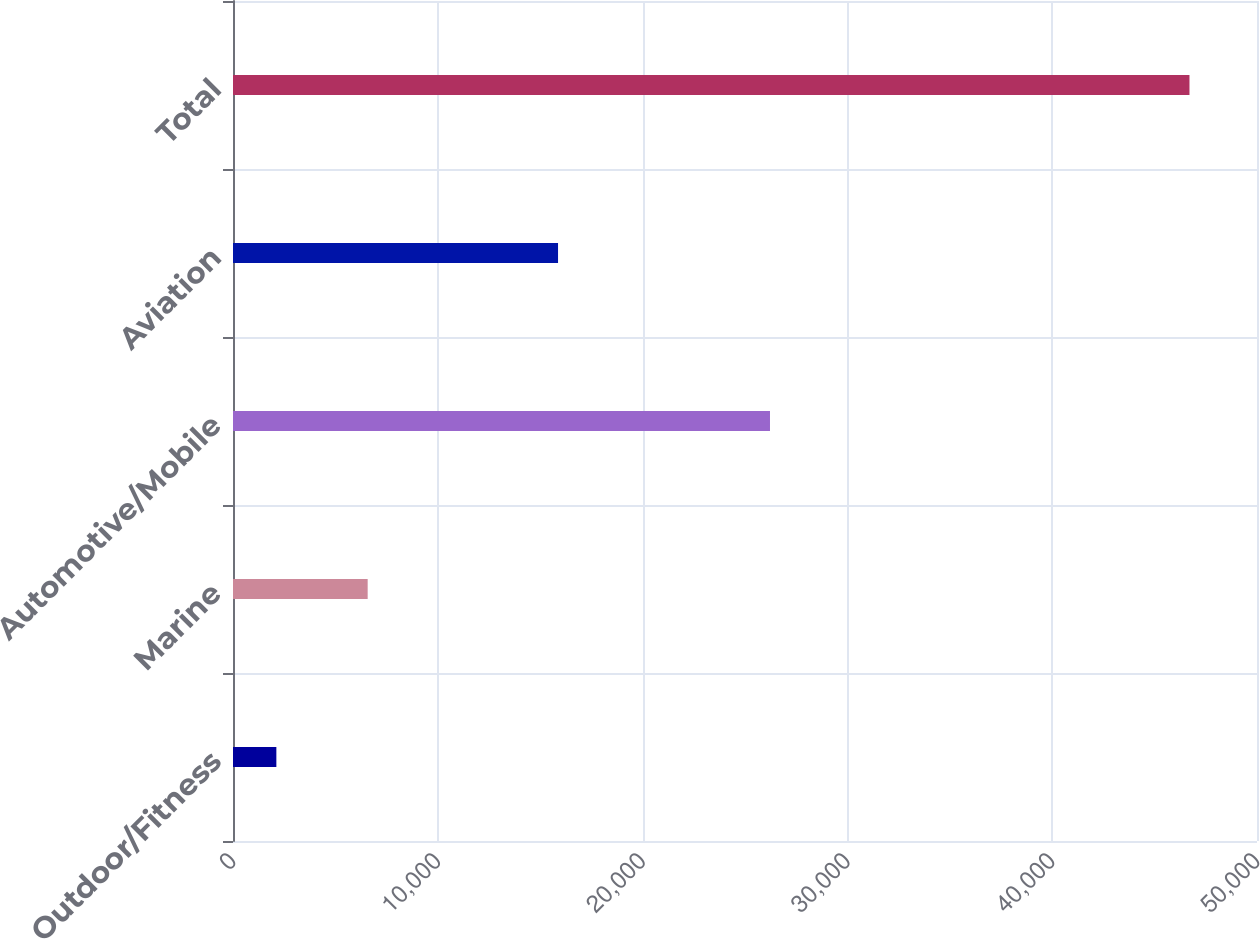Convert chart. <chart><loc_0><loc_0><loc_500><loc_500><bar_chart><fcel>Outdoor/Fitness<fcel>Marine<fcel>Automotive/Mobile<fcel>Aviation<fcel>Total<nl><fcel>2117<fcel>6575.6<fcel>26220<fcel>15871<fcel>46703<nl></chart> 